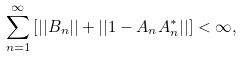Convert formula to latex. <formula><loc_0><loc_0><loc_500><loc_500>\sum _ { n = 1 } ^ { \infty } \left [ | | B _ { n } | | + | | 1 - A _ { n } A _ { n } ^ { * } | | \right ] < \infty ,</formula> 